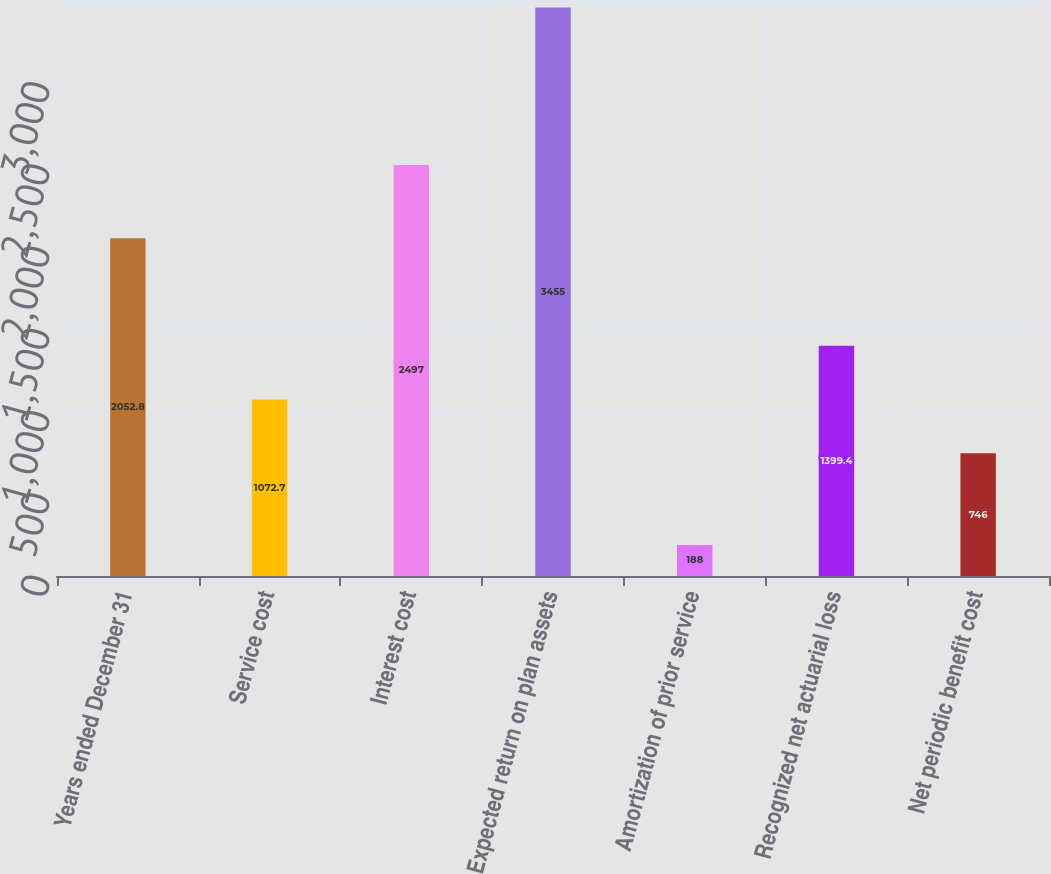Convert chart to OTSL. <chart><loc_0><loc_0><loc_500><loc_500><bar_chart><fcel>Years ended December 31<fcel>Service cost<fcel>Interest cost<fcel>Expected return on plan assets<fcel>Amortization of prior service<fcel>Recognized net actuarial loss<fcel>Net periodic benefit cost<nl><fcel>2052.8<fcel>1072.7<fcel>2497<fcel>3455<fcel>188<fcel>1399.4<fcel>746<nl></chart> 